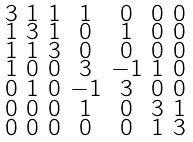<formula> <loc_0><loc_0><loc_500><loc_500>\begin{smallmatrix} 3 & 1 & 1 & 1 & 0 & 0 & 0 \\ 1 & 3 & 1 & 0 & 1 & 0 & 0 \\ 1 & 1 & 3 & 0 & 0 & 0 & 0 \\ 1 & 0 & 0 & 3 & - 1 & 1 & 0 \\ 0 & 1 & 0 & - 1 & 3 & 0 & 0 \\ 0 & 0 & 0 & 1 & 0 & 3 & 1 \\ 0 & 0 & 0 & 0 & 0 & 1 & 3 \end{smallmatrix}</formula> 